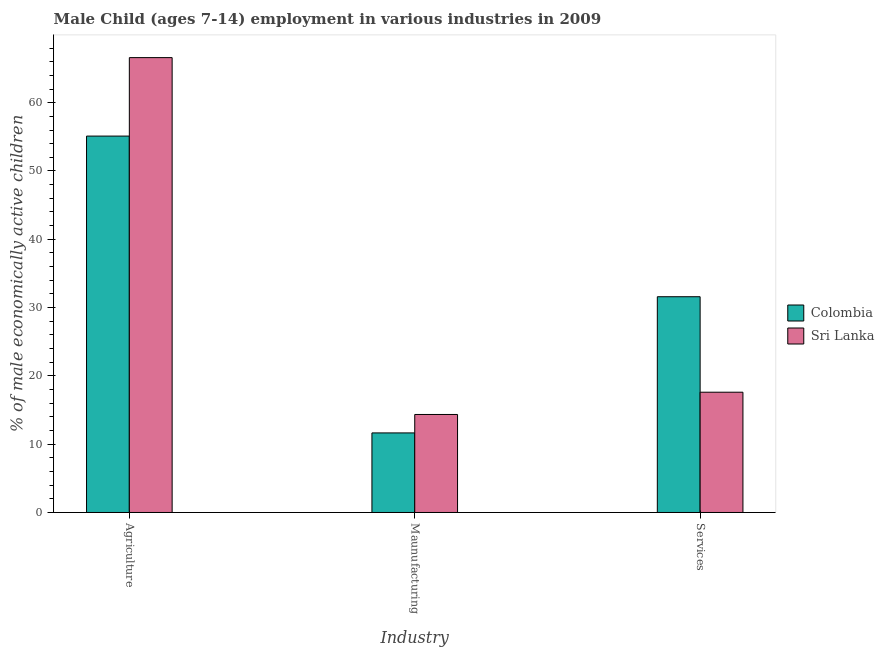Are the number of bars per tick equal to the number of legend labels?
Provide a succinct answer. Yes. How many bars are there on the 1st tick from the right?
Offer a very short reply. 2. What is the label of the 3rd group of bars from the left?
Keep it short and to the point. Services. What is the percentage of economically active children in agriculture in Sri Lanka?
Your answer should be compact. 66.6. Across all countries, what is the maximum percentage of economically active children in services?
Give a very brief answer. 31.59. Across all countries, what is the minimum percentage of economically active children in services?
Offer a terse response. 17.61. In which country was the percentage of economically active children in manufacturing maximum?
Offer a very short reply. Sri Lanka. In which country was the percentage of economically active children in services minimum?
Your answer should be compact. Sri Lanka. What is the total percentage of economically active children in agriculture in the graph?
Your response must be concise. 121.71. What is the difference between the percentage of economically active children in services in Sri Lanka and that in Colombia?
Provide a succinct answer. -13.98. What is the difference between the percentage of economically active children in services in Colombia and the percentage of economically active children in manufacturing in Sri Lanka?
Offer a very short reply. 17.24. What is the average percentage of economically active children in agriculture per country?
Ensure brevity in your answer.  60.85. What is the difference between the percentage of economically active children in services and percentage of economically active children in manufacturing in Sri Lanka?
Your answer should be compact. 3.26. In how many countries, is the percentage of economically active children in services greater than 6 %?
Offer a very short reply. 2. What is the ratio of the percentage of economically active children in agriculture in Sri Lanka to that in Colombia?
Provide a succinct answer. 1.21. Is the percentage of economically active children in services in Sri Lanka less than that in Colombia?
Provide a short and direct response. Yes. What is the difference between the highest and the second highest percentage of economically active children in services?
Provide a short and direct response. 13.98. What is the difference between the highest and the lowest percentage of economically active children in agriculture?
Your answer should be very brief. 11.49. Is the sum of the percentage of economically active children in services in Sri Lanka and Colombia greater than the maximum percentage of economically active children in manufacturing across all countries?
Your answer should be very brief. Yes. What does the 2nd bar from the left in Services represents?
Offer a terse response. Sri Lanka. Is it the case that in every country, the sum of the percentage of economically active children in agriculture and percentage of economically active children in manufacturing is greater than the percentage of economically active children in services?
Ensure brevity in your answer.  Yes. How many countries are there in the graph?
Your response must be concise. 2. What is the difference between two consecutive major ticks on the Y-axis?
Provide a succinct answer. 10. What is the title of the graph?
Offer a terse response. Male Child (ages 7-14) employment in various industries in 2009. What is the label or title of the X-axis?
Offer a very short reply. Industry. What is the label or title of the Y-axis?
Ensure brevity in your answer.  % of male economically active children. What is the % of male economically active children of Colombia in Agriculture?
Offer a very short reply. 55.11. What is the % of male economically active children of Sri Lanka in Agriculture?
Offer a very short reply. 66.6. What is the % of male economically active children in Colombia in Maunufacturing?
Offer a very short reply. 11.65. What is the % of male economically active children of Sri Lanka in Maunufacturing?
Your answer should be very brief. 14.35. What is the % of male economically active children of Colombia in Services?
Provide a short and direct response. 31.59. What is the % of male economically active children in Sri Lanka in Services?
Give a very brief answer. 17.61. Across all Industry, what is the maximum % of male economically active children of Colombia?
Provide a succinct answer. 55.11. Across all Industry, what is the maximum % of male economically active children of Sri Lanka?
Make the answer very short. 66.6. Across all Industry, what is the minimum % of male economically active children of Colombia?
Your response must be concise. 11.65. Across all Industry, what is the minimum % of male economically active children in Sri Lanka?
Provide a succinct answer. 14.35. What is the total % of male economically active children of Colombia in the graph?
Keep it short and to the point. 98.35. What is the total % of male economically active children in Sri Lanka in the graph?
Provide a succinct answer. 98.56. What is the difference between the % of male economically active children of Colombia in Agriculture and that in Maunufacturing?
Your response must be concise. 43.46. What is the difference between the % of male economically active children in Sri Lanka in Agriculture and that in Maunufacturing?
Make the answer very short. 52.25. What is the difference between the % of male economically active children in Colombia in Agriculture and that in Services?
Keep it short and to the point. 23.52. What is the difference between the % of male economically active children in Sri Lanka in Agriculture and that in Services?
Ensure brevity in your answer.  48.99. What is the difference between the % of male economically active children of Colombia in Maunufacturing and that in Services?
Provide a succinct answer. -19.94. What is the difference between the % of male economically active children in Sri Lanka in Maunufacturing and that in Services?
Your response must be concise. -3.26. What is the difference between the % of male economically active children of Colombia in Agriculture and the % of male economically active children of Sri Lanka in Maunufacturing?
Offer a terse response. 40.76. What is the difference between the % of male economically active children of Colombia in Agriculture and the % of male economically active children of Sri Lanka in Services?
Your response must be concise. 37.5. What is the difference between the % of male economically active children in Colombia in Maunufacturing and the % of male economically active children in Sri Lanka in Services?
Provide a short and direct response. -5.96. What is the average % of male economically active children of Colombia per Industry?
Your answer should be compact. 32.78. What is the average % of male economically active children of Sri Lanka per Industry?
Make the answer very short. 32.85. What is the difference between the % of male economically active children of Colombia and % of male economically active children of Sri Lanka in Agriculture?
Offer a terse response. -11.49. What is the difference between the % of male economically active children of Colombia and % of male economically active children of Sri Lanka in Maunufacturing?
Offer a terse response. -2.7. What is the difference between the % of male economically active children of Colombia and % of male economically active children of Sri Lanka in Services?
Your answer should be compact. 13.98. What is the ratio of the % of male economically active children of Colombia in Agriculture to that in Maunufacturing?
Ensure brevity in your answer.  4.73. What is the ratio of the % of male economically active children in Sri Lanka in Agriculture to that in Maunufacturing?
Provide a short and direct response. 4.64. What is the ratio of the % of male economically active children of Colombia in Agriculture to that in Services?
Keep it short and to the point. 1.74. What is the ratio of the % of male economically active children in Sri Lanka in Agriculture to that in Services?
Offer a terse response. 3.78. What is the ratio of the % of male economically active children in Colombia in Maunufacturing to that in Services?
Your answer should be very brief. 0.37. What is the ratio of the % of male economically active children of Sri Lanka in Maunufacturing to that in Services?
Keep it short and to the point. 0.81. What is the difference between the highest and the second highest % of male economically active children in Colombia?
Keep it short and to the point. 23.52. What is the difference between the highest and the second highest % of male economically active children of Sri Lanka?
Offer a terse response. 48.99. What is the difference between the highest and the lowest % of male economically active children in Colombia?
Make the answer very short. 43.46. What is the difference between the highest and the lowest % of male economically active children in Sri Lanka?
Your response must be concise. 52.25. 